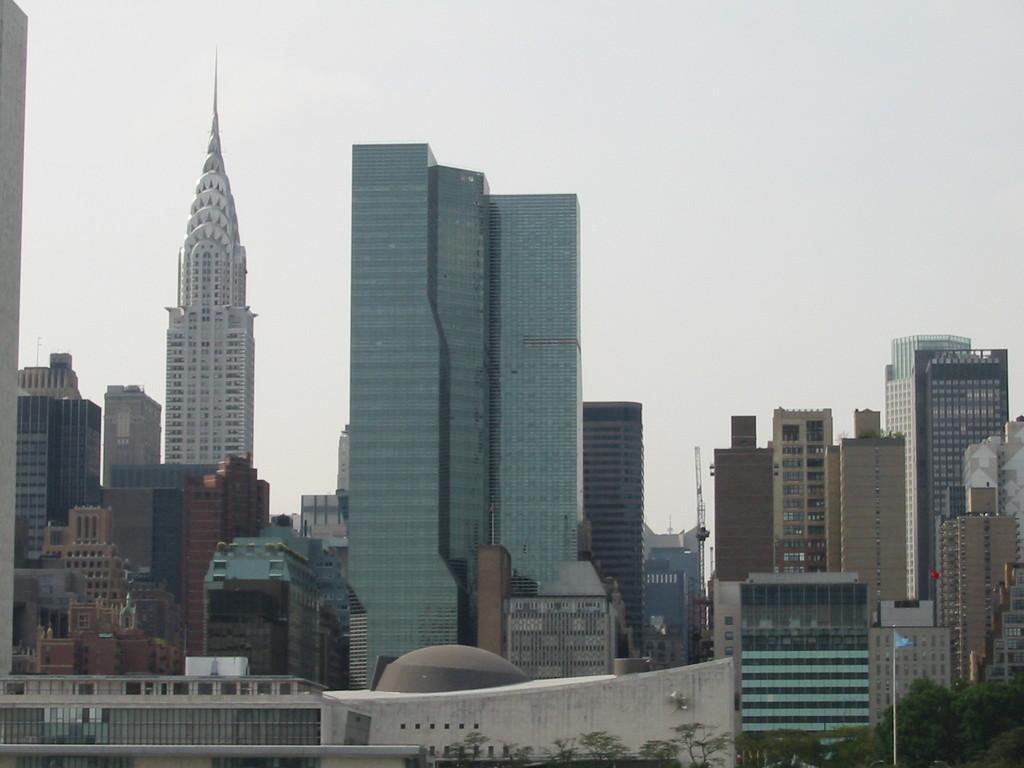Please provide a concise description of this image. In this image I can see few buildings around. In front I can see trees and blue color flag. The sky is in white color. 